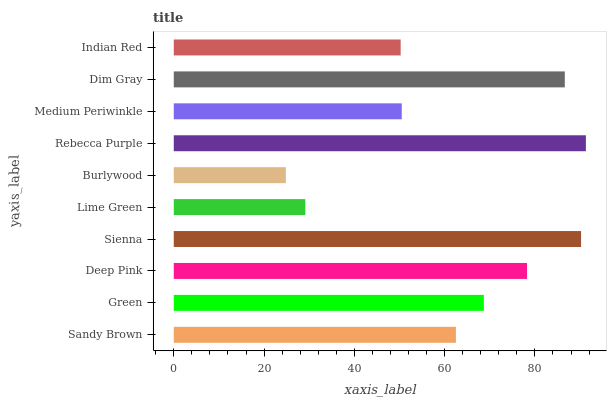Is Burlywood the minimum?
Answer yes or no. Yes. Is Rebecca Purple the maximum?
Answer yes or no. Yes. Is Green the minimum?
Answer yes or no. No. Is Green the maximum?
Answer yes or no. No. Is Green greater than Sandy Brown?
Answer yes or no. Yes. Is Sandy Brown less than Green?
Answer yes or no. Yes. Is Sandy Brown greater than Green?
Answer yes or no. No. Is Green less than Sandy Brown?
Answer yes or no. No. Is Green the high median?
Answer yes or no. Yes. Is Sandy Brown the low median?
Answer yes or no. Yes. Is Lime Green the high median?
Answer yes or no. No. Is Dim Gray the low median?
Answer yes or no. No. 